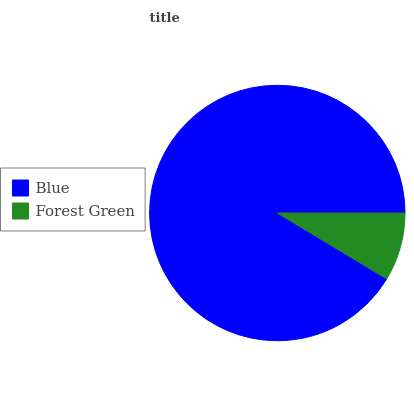Is Forest Green the minimum?
Answer yes or no. Yes. Is Blue the maximum?
Answer yes or no. Yes. Is Forest Green the maximum?
Answer yes or no. No. Is Blue greater than Forest Green?
Answer yes or no. Yes. Is Forest Green less than Blue?
Answer yes or no. Yes. Is Forest Green greater than Blue?
Answer yes or no. No. Is Blue less than Forest Green?
Answer yes or no. No. Is Blue the high median?
Answer yes or no. Yes. Is Forest Green the low median?
Answer yes or no. Yes. Is Forest Green the high median?
Answer yes or no. No. Is Blue the low median?
Answer yes or no. No. 